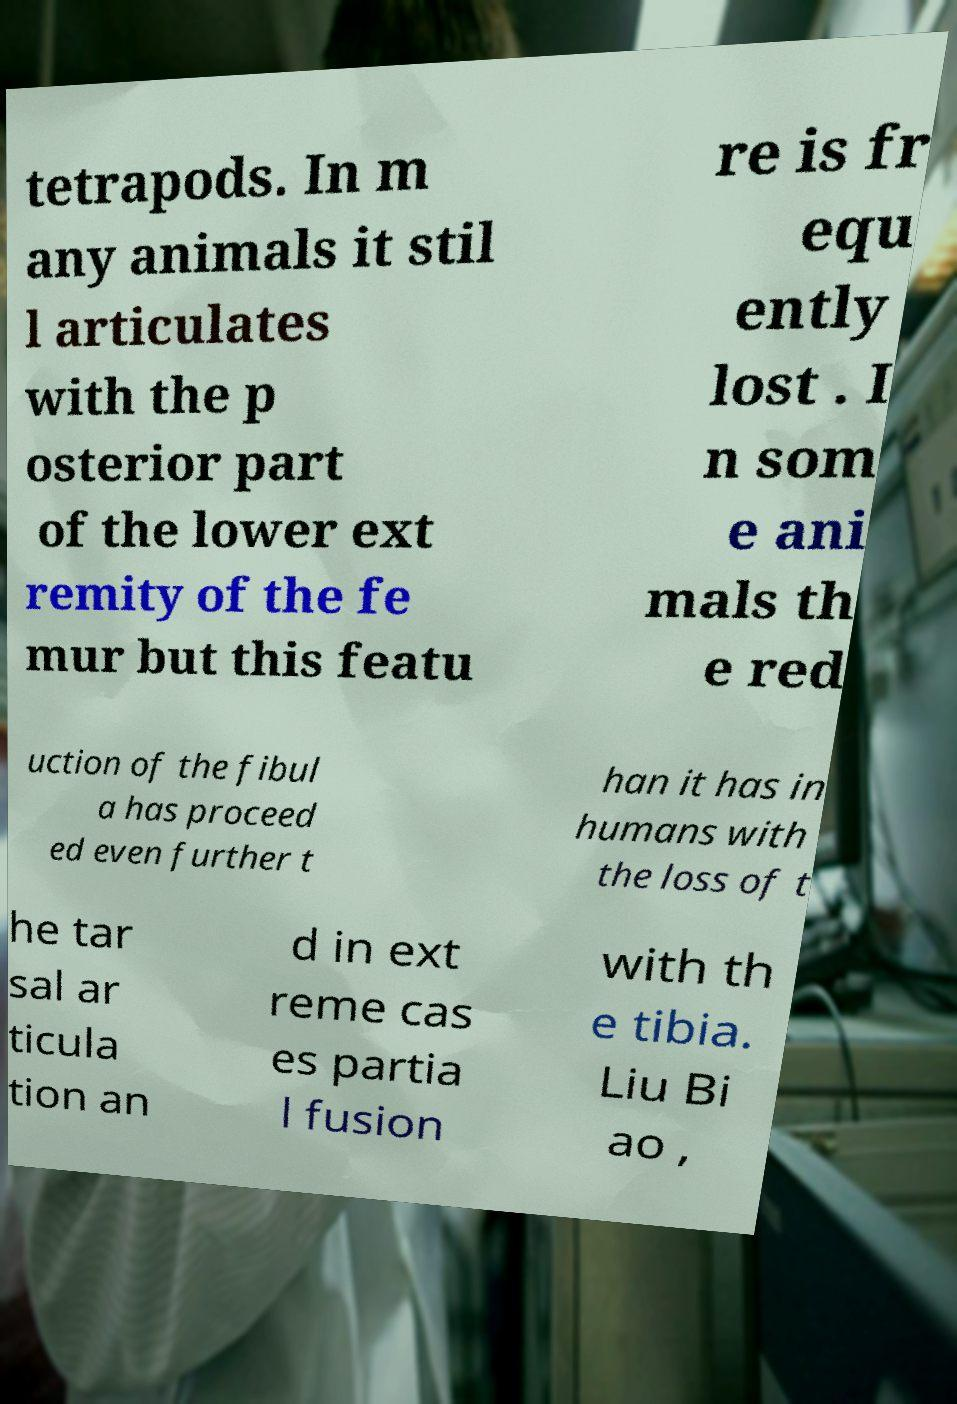Can you accurately transcribe the text from the provided image for me? tetrapods. In m any animals it stil l articulates with the p osterior part of the lower ext remity of the fe mur but this featu re is fr equ ently lost . I n som e ani mals th e red uction of the fibul a has proceed ed even further t han it has in humans with the loss of t he tar sal ar ticula tion an d in ext reme cas es partia l fusion with th e tibia. Liu Bi ao , 